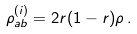Convert formula to latex. <formula><loc_0><loc_0><loc_500><loc_500>\rho _ { a b } ^ { ( i ) } = 2 r ( 1 - r ) \rho \, .</formula> 